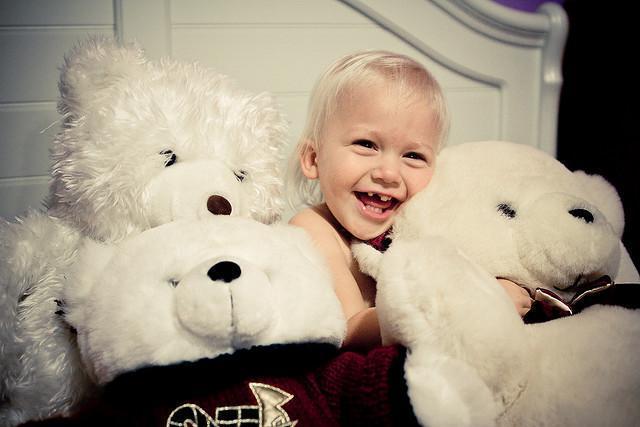How many teddy bears can be seen?
Give a very brief answer. 3. 